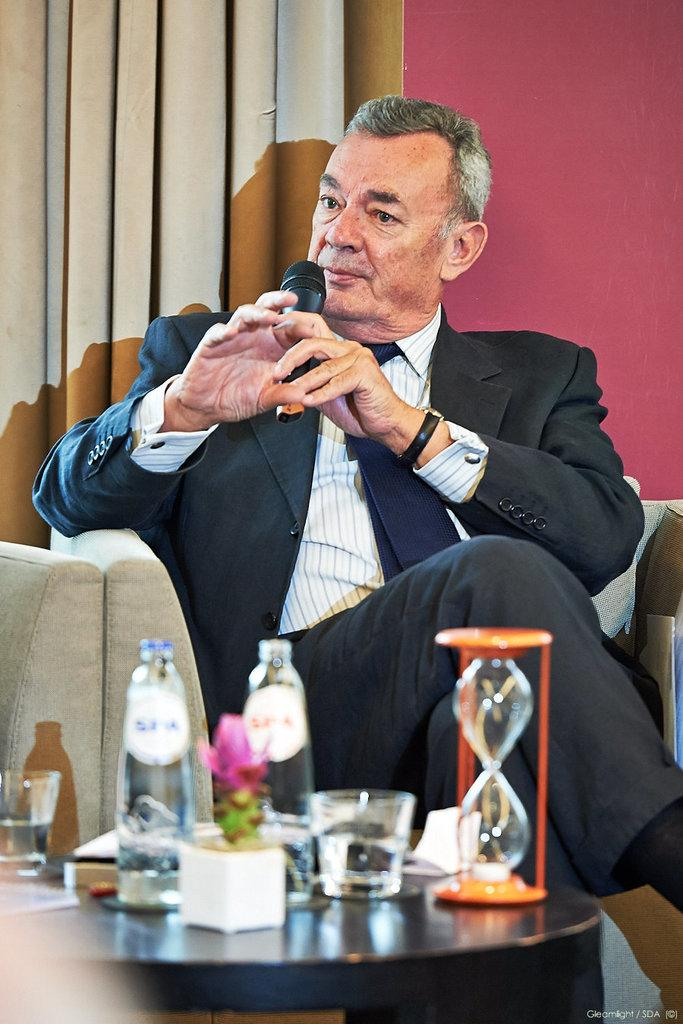What is the man in the image doing? The man is sitting on a sofa. What is the man holding in the image? The man is holding a microphone. What objects can be seen on the table in the image? There are bottles on a table. What type of question is the man asking in the image? There is no indication in the image that the man is asking a question, as he is holding a microphone, which suggests he might be speaking or performing. 